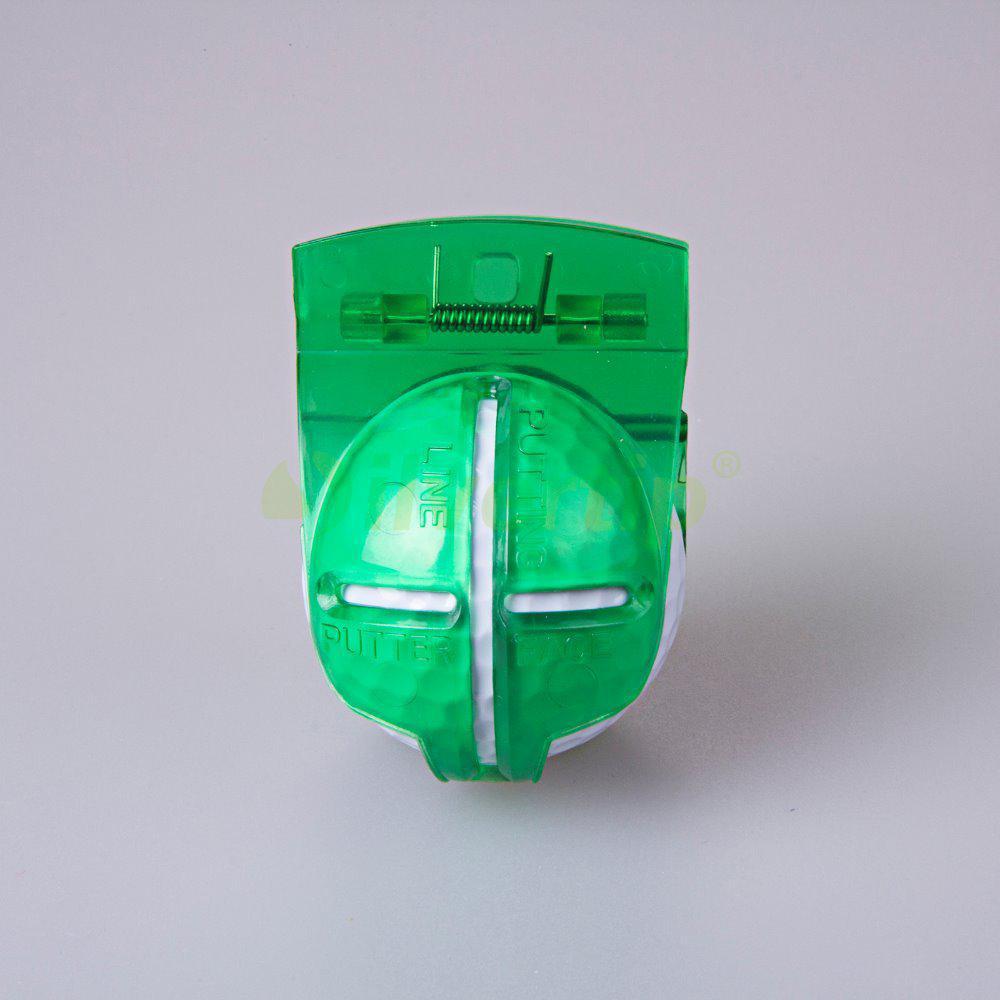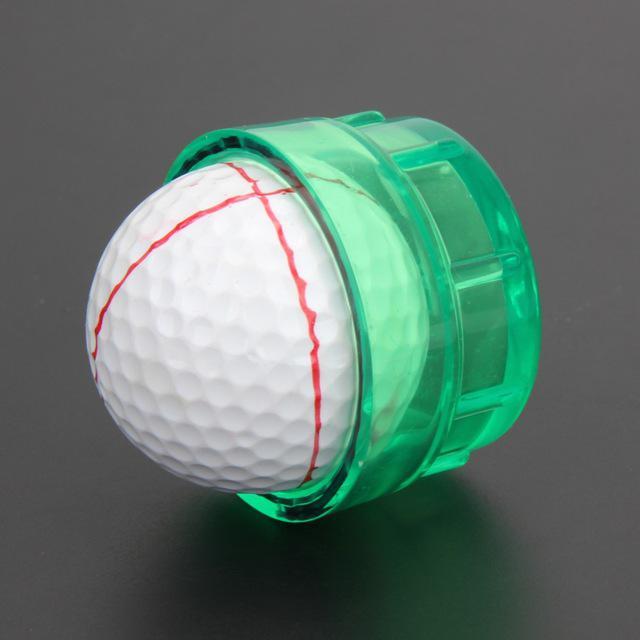The first image is the image on the left, the second image is the image on the right. Considering the images on both sides, is "There are only two golf balls, and both of them are in translucent green containers." valid? Answer yes or no. Yes. The first image is the image on the left, the second image is the image on the right. Given the left and right images, does the statement "In one of the images there is a golf ball with red lines on it." hold true? Answer yes or no. Yes. 